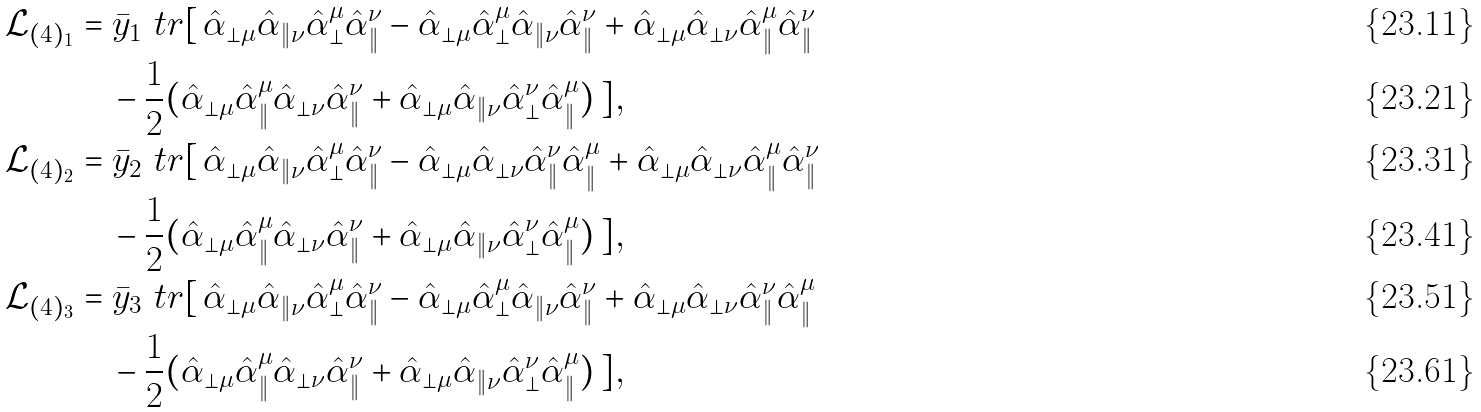Convert formula to latex. <formula><loc_0><loc_0><loc_500><loc_500>\mathcal { L } _ { ( 4 ) _ { 1 } } & = \bar { y } _ { 1 } \ t r [ \, \hat { \alpha } _ { \perp \mu } \hat { \alpha } _ { \| \nu } \hat { \alpha } ^ { \mu } _ { \perp } \hat { \alpha } ^ { \nu } _ { \| } - \hat { \alpha } _ { \perp \mu } \hat { \alpha } ^ { \mu } _ { \perp } \hat { \alpha } _ { \| \nu } \hat { \alpha } ^ { \nu } _ { \| } + \hat { \alpha } _ { \perp \mu } \hat { \alpha } _ { \perp \nu } \hat { \alpha } ^ { \mu } _ { \| } \hat { \alpha } ^ { \nu } _ { \| } \\ & \quad - \frac { 1 } { 2 } ( \hat { \alpha } _ { \perp \mu } \hat { \alpha } ^ { \mu } _ { \| } \hat { \alpha } _ { \perp \nu } \hat { \alpha } ^ { \nu } _ { \| } + \hat { \alpha } _ { \perp \mu } \hat { \alpha } _ { \| \nu } \hat { \alpha } ^ { \nu } _ { \perp } \hat { \alpha } ^ { \mu } _ { \| } ) \, ] , \\ \mathcal { L } _ { ( 4 ) _ { 2 } } & = \bar { y } _ { 2 } \ t r [ \, \hat { \alpha } _ { \perp \mu } \hat { \alpha } _ { \| \nu } \hat { \alpha } ^ { \mu } _ { \perp } \hat { \alpha } ^ { \nu } _ { \| } - \hat { \alpha } _ { \perp \mu } \hat { \alpha } _ { \perp \nu } \hat { \alpha } ^ { \nu } _ { \| } \hat { \alpha } ^ { \mu } _ { \| } + \hat { \alpha } _ { \perp \mu } \hat { \alpha } _ { \perp \nu } \hat { \alpha } ^ { \mu } _ { \| } \hat { \alpha } ^ { \nu } _ { \| } \\ & \quad - \frac { 1 } { 2 } ( \hat { \alpha } _ { \perp \mu } \hat { \alpha } ^ { \mu } _ { \| } \hat { \alpha } _ { \perp \nu } \hat { \alpha } ^ { \nu } _ { \| } + \hat { \alpha } _ { \perp \mu } \hat { \alpha } _ { \| \nu } \hat { \alpha } ^ { \nu } _ { \perp } \hat { \alpha } ^ { \mu } _ { \| } ) \, ] , \\ \mathcal { L } _ { ( 4 ) _ { 3 } } & = \bar { y } _ { 3 } \ t r [ \, \hat { \alpha } _ { \perp \mu } \hat { \alpha } _ { \| \nu } \hat { \alpha } ^ { \mu } _ { \perp } \hat { \alpha } ^ { \nu } _ { \| } - \hat { \alpha } _ { \perp \mu } \hat { \alpha } ^ { \mu } _ { \perp } \hat { \alpha } _ { \| \nu } \hat { \alpha } ^ { \nu } _ { \| } + \hat { \alpha } _ { \perp \mu } \hat { \alpha } _ { \perp \nu } \hat { \alpha } ^ { \nu } _ { \| } \hat { \alpha } ^ { \mu } _ { \| } \\ & \quad - \frac { 1 } { 2 } ( \hat { \alpha } _ { \perp \mu } \hat { \alpha } ^ { \mu } _ { \| } \hat { \alpha } _ { \perp \nu } \hat { \alpha } ^ { \nu } _ { \| } + \hat { \alpha } _ { \perp \mu } \hat { \alpha } _ { \| \nu } \hat { \alpha } ^ { \nu } _ { \perp } \hat { \alpha } ^ { \mu } _ { \| } ) \, ] ,</formula> 